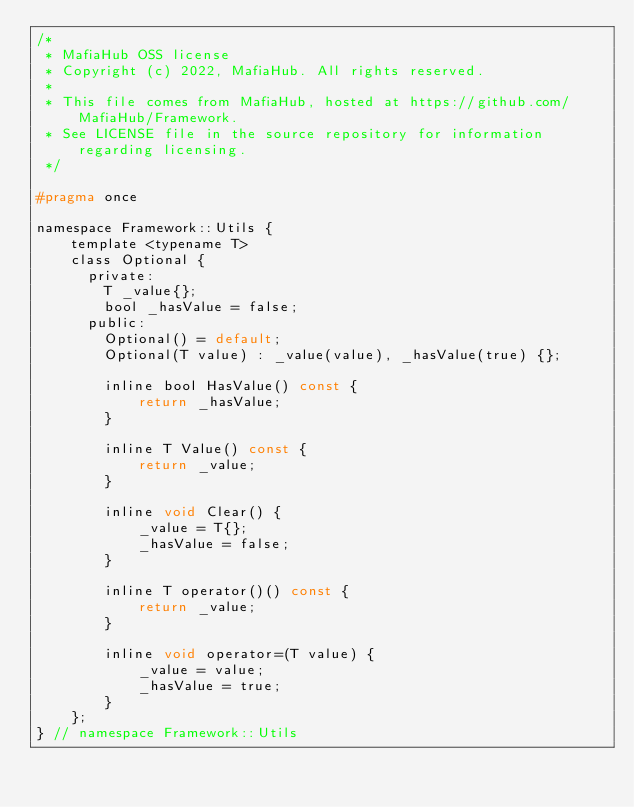<code> <loc_0><loc_0><loc_500><loc_500><_C_>/*
 * MafiaHub OSS license
 * Copyright (c) 2022, MafiaHub. All rights reserved.
 *
 * This file comes from MafiaHub, hosted at https://github.com/MafiaHub/Framework.
 * See LICENSE file in the source repository for information regarding licensing.
 */

#pragma once

namespace Framework::Utils {
    template <typename T>
    class Optional {
      private:
        T _value{};
        bool _hasValue = false;
      public:
        Optional() = default;
        Optional(T value) : _value(value), _hasValue(true) {};

        inline bool HasValue() const {
            return _hasValue;
        }

        inline T Value() const {
            return _value;
        }

        inline void Clear() {
            _value = T{};
            _hasValue = false;
        }

        inline T operator()() const {
            return _value;
        }

        inline void operator=(T value) {
            _value = value;
            _hasValue = true;
        }
    };
} // namespace Framework::Utils
</code> 